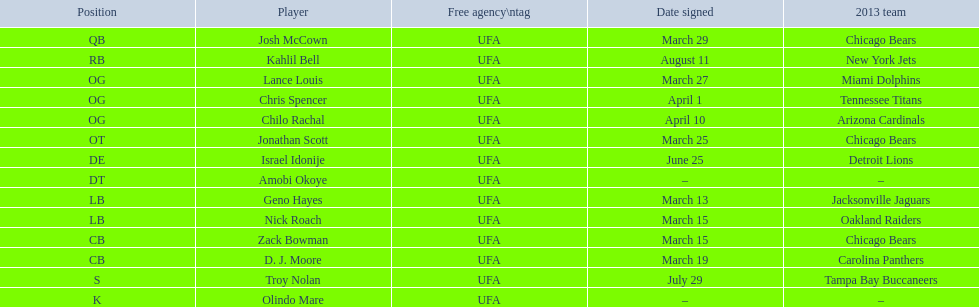Who are all of the players? Josh McCown, Kahlil Bell, Lance Louis, Chris Spencer, Chilo Rachal, Jonathan Scott, Israel Idonije, Amobi Okoye, Geno Hayes, Nick Roach, Zack Bowman, D. J. Moore, Troy Nolan, Olindo Mare. When were they signed? March 29, August 11, March 27, April 1, April 10, March 25, June 25, –, March 13, March 15, March 15, March 19, July 29, –. Along with nick roach, who else was signed on march 15? Zack Bowman. 